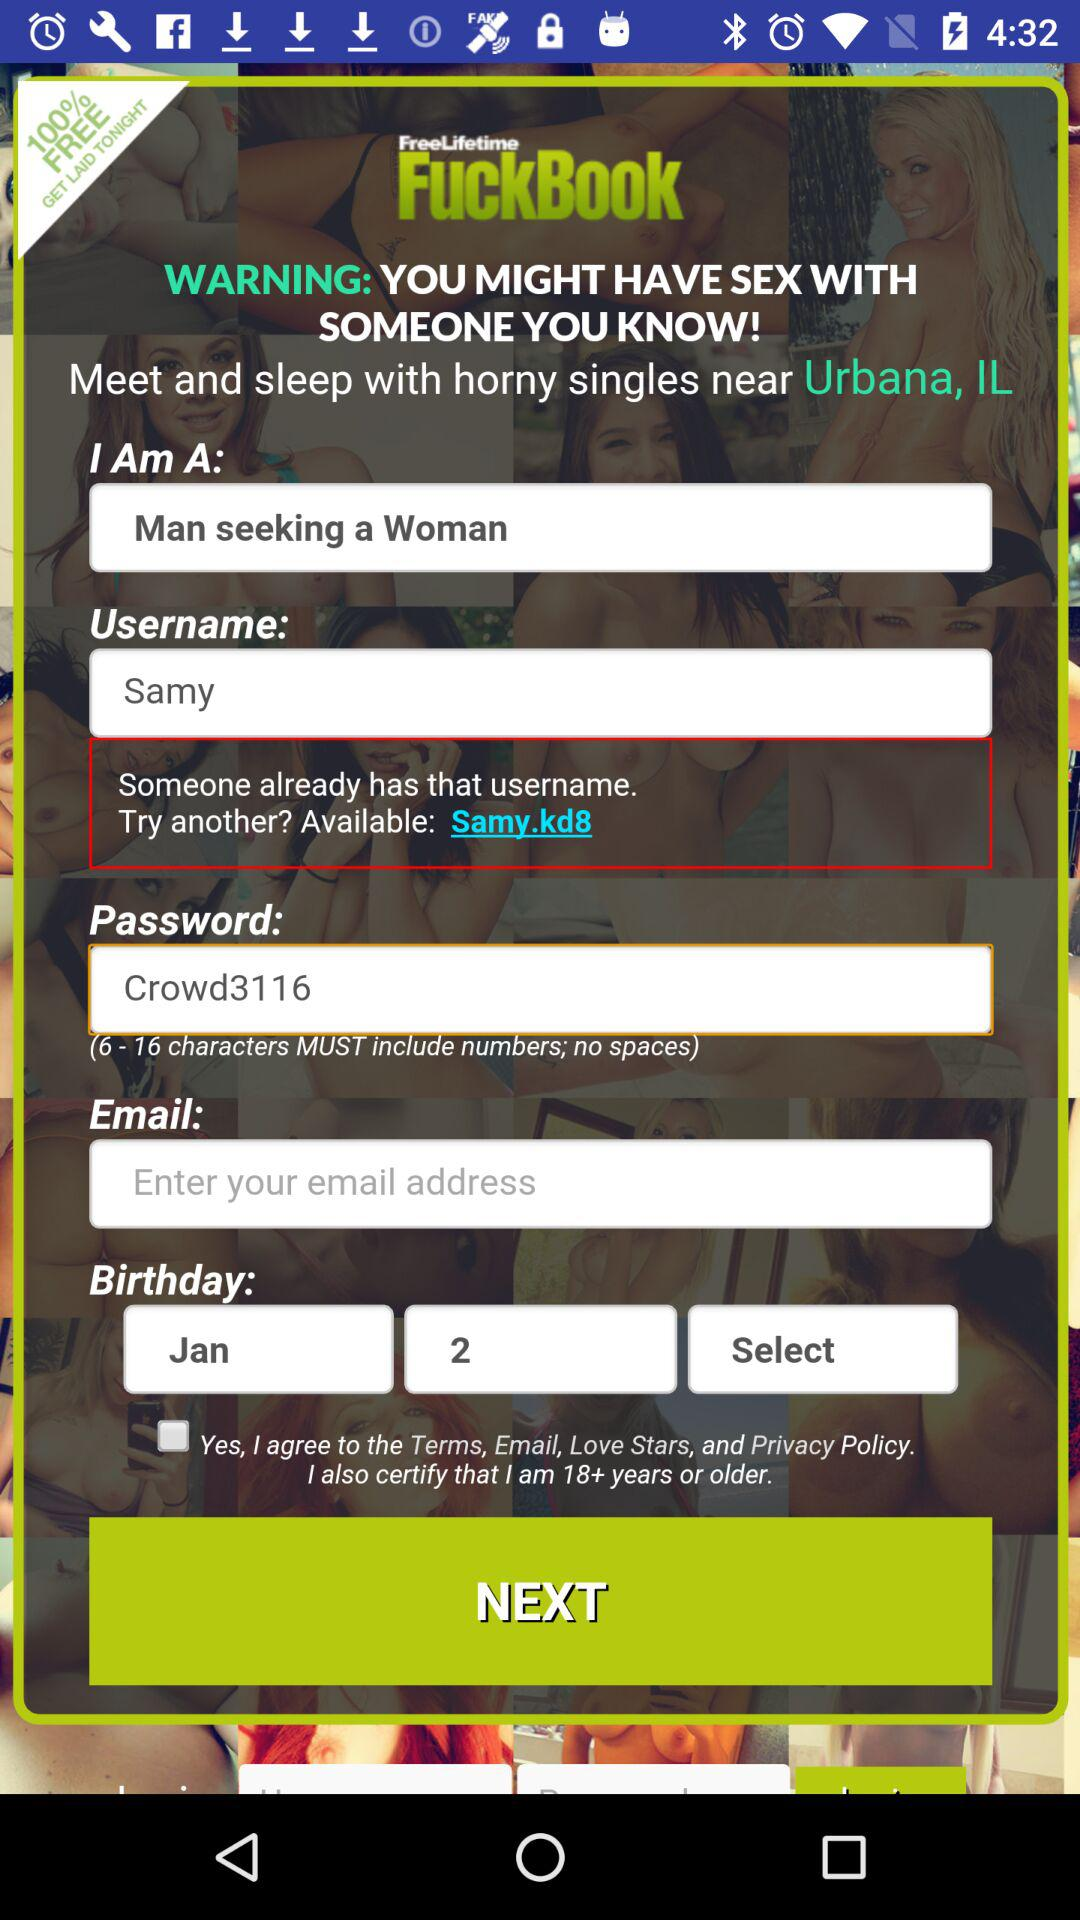What is the user name? The username is Samy. 